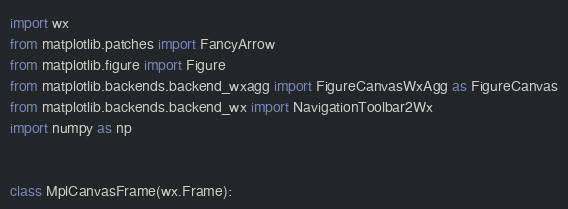<code> <loc_0><loc_0><loc_500><loc_500><_Python_>import wx
from matplotlib.patches import FancyArrow
from matplotlib.figure import Figure
from matplotlib.backends.backend_wxagg import FigureCanvasWxAgg as FigureCanvas
from matplotlib.backends.backend_wx import NavigationToolbar2Wx
import numpy as np


class MplCanvasFrame(wx.Frame):</code> 